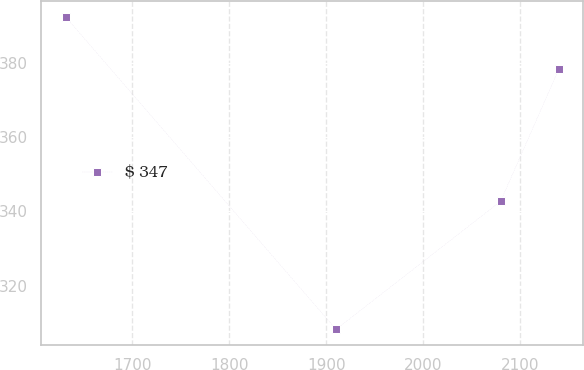Convert chart. <chart><loc_0><loc_0><loc_500><loc_500><line_chart><ecel><fcel>$ 347<nl><fcel>1631.38<fcel>392.49<nl><fcel>1910.06<fcel>308.18<nl><fcel>2079.63<fcel>342.74<nl><fcel>2139.61<fcel>378.38<nl></chart> 